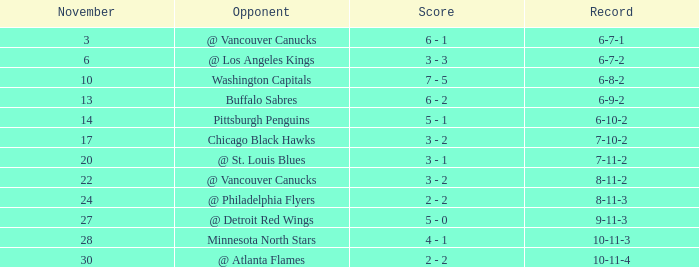What is the game when on november 27? 23.0. 